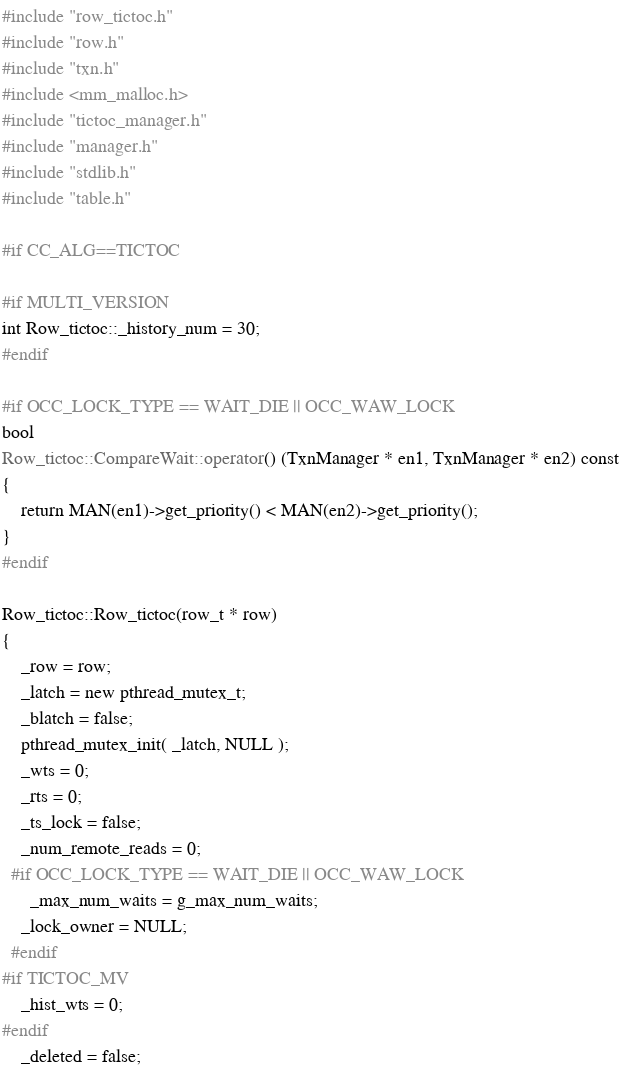Convert code to text. <code><loc_0><loc_0><loc_500><loc_500><_C++_>#include "row_tictoc.h"
#include "row.h"
#include "txn.h"
#include <mm_malloc.h>
#include "tictoc_manager.h"
#include "manager.h"
#include "stdlib.h"
#include "table.h"

#if CC_ALG==TICTOC

#if MULTI_VERSION
int Row_tictoc::_history_num = 30;
#endif

#if OCC_LOCK_TYPE == WAIT_DIE || OCC_WAW_LOCK
bool
Row_tictoc::CompareWait::operator() (TxnManager * en1, TxnManager * en2) const
{
    return MAN(en1)->get_priority() < MAN(en2)->get_priority();
}
#endif

Row_tictoc::Row_tictoc(row_t * row)
{
    _row = row;
    _latch = new pthread_mutex_t;
    _blatch = false;
    pthread_mutex_init( _latch, NULL );
    _wts = 0;
    _rts = 0;
    _ts_lock = false;
    _num_remote_reads = 0;
  #if OCC_LOCK_TYPE == WAIT_DIE || OCC_WAW_LOCK
      _max_num_waits = g_max_num_waits;
    _lock_owner = NULL;
  #endif
#if TICTOC_MV
    _hist_wts = 0;
#endif
    _deleted = false;</code> 